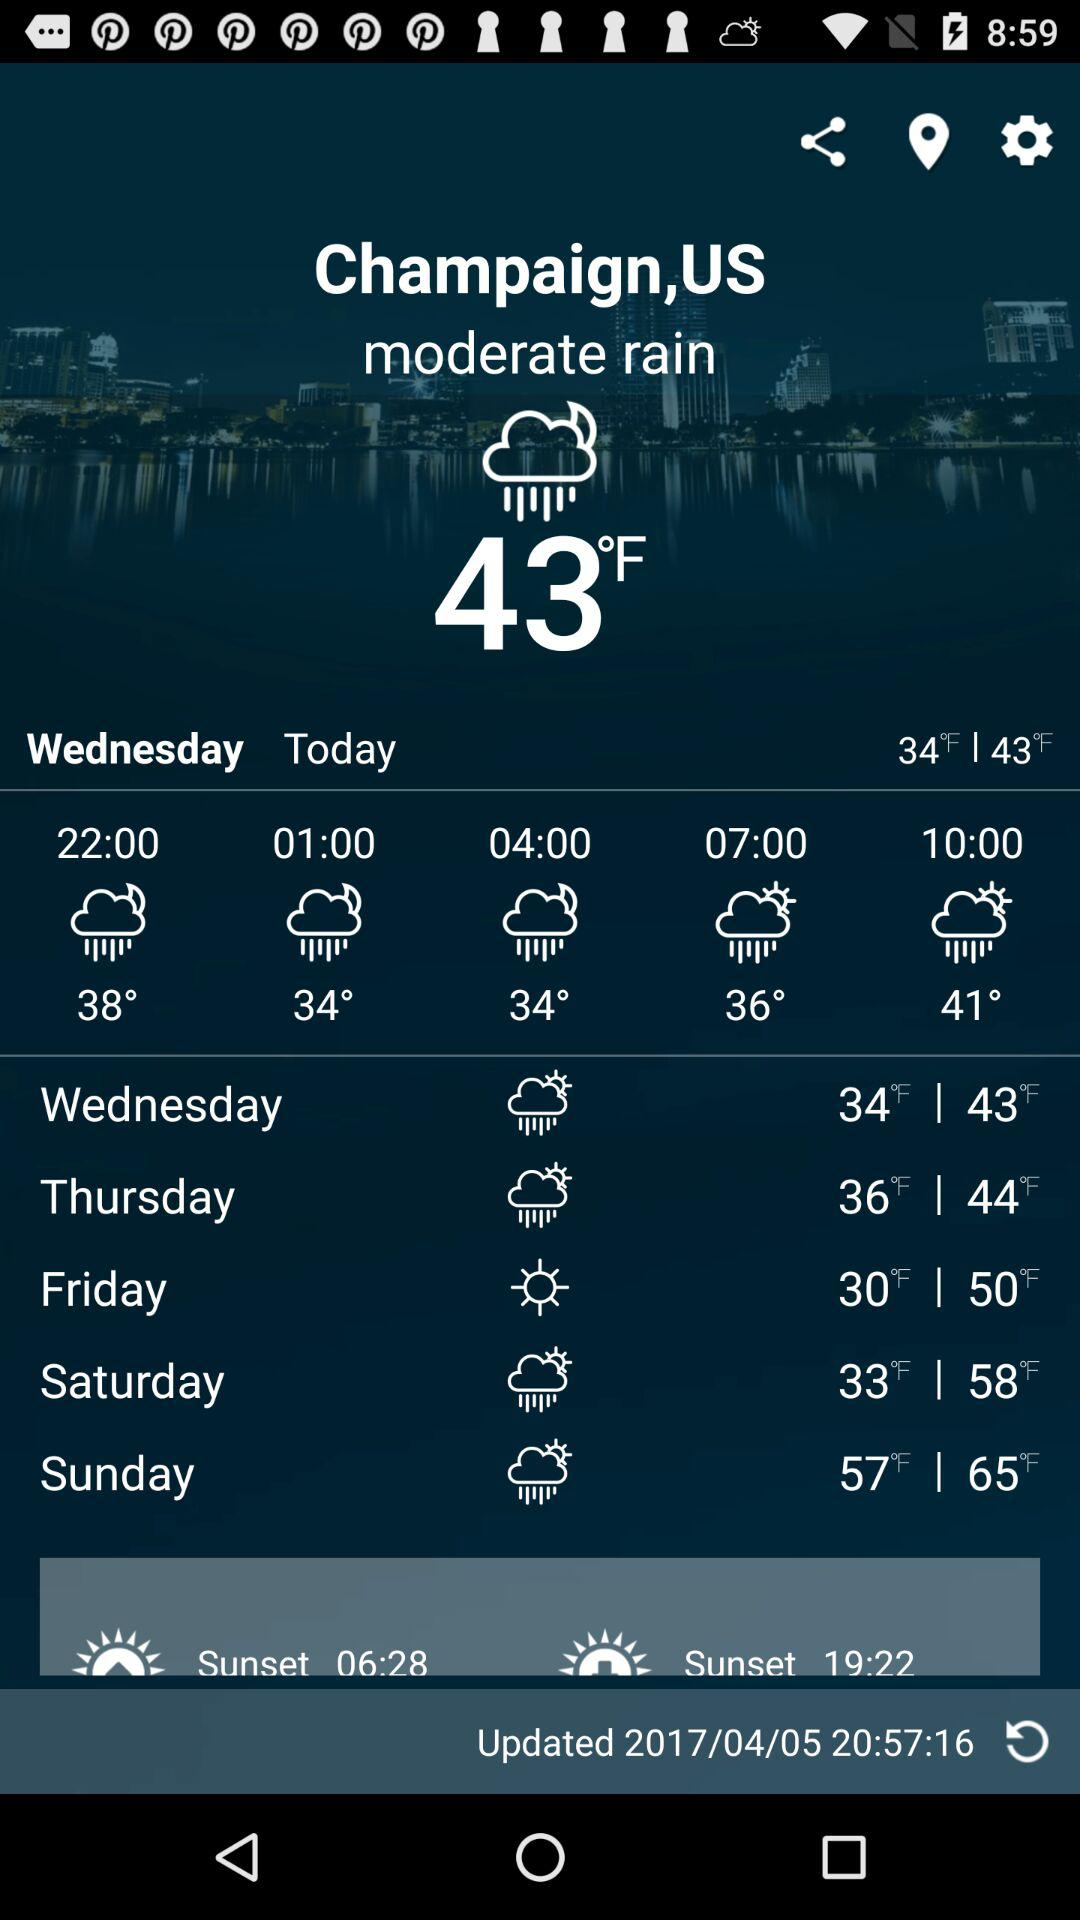When was the weather last updated? The weather was last updated on April 5, 2017 at 20:57:16. 